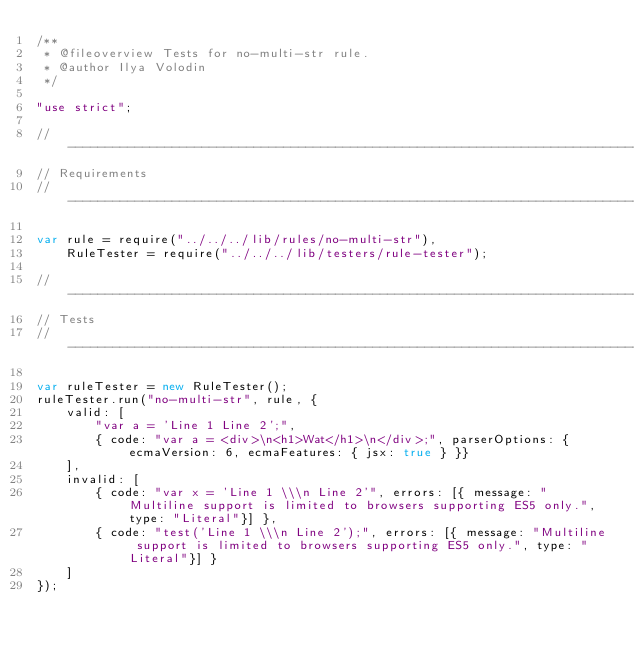<code> <loc_0><loc_0><loc_500><loc_500><_JavaScript_>/**
 * @fileoverview Tests for no-multi-str rule.
 * @author Ilya Volodin
 */

"use strict";

//------------------------------------------------------------------------------
// Requirements
//------------------------------------------------------------------------------

var rule = require("../../../lib/rules/no-multi-str"),
    RuleTester = require("../../../lib/testers/rule-tester");

//------------------------------------------------------------------------------
// Tests
//------------------------------------------------------------------------------

var ruleTester = new RuleTester();
ruleTester.run("no-multi-str", rule, {
    valid: [
        "var a = 'Line 1 Line 2';",
        { code: "var a = <div>\n<h1>Wat</h1>\n</div>;", parserOptions: { ecmaVersion: 6, ecmaFeatures: { jsx: true } }}
    ],
    invalid: [
        { code: "var x = 'Line 1 \\\n Line 2'", errors: [{ message: "Multiline support is limited to browsers supporting ES5 only.", type: "Literal"}] },
        { code: "test('Line 1 \\\n Line 2');", errors: [{ message: "Multiline support is limited to browsers supporting ES5 only.", type: "Literal"}] }
    ]
});
</code> 